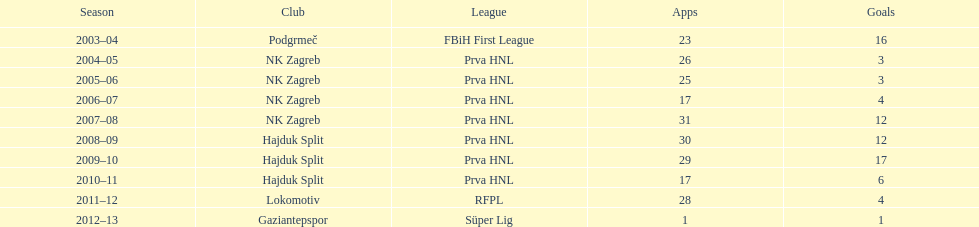What is senijad ibricic's record for the most goals scored during one season? 35. 